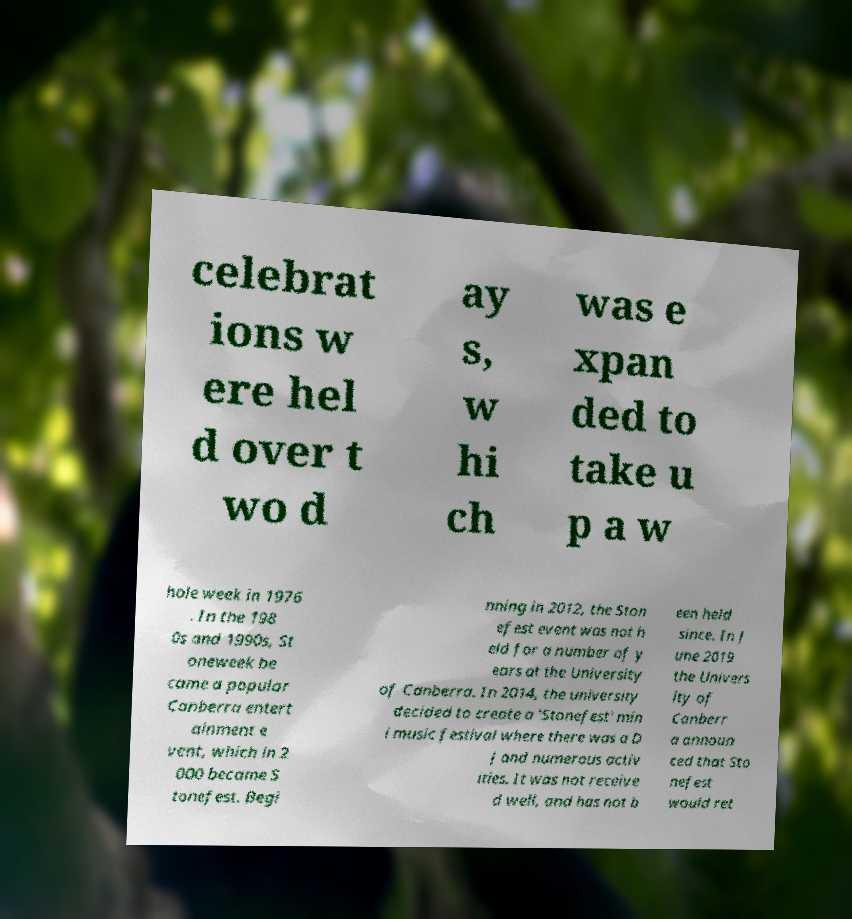For documentation purposes, I need the text within this image transcribed. Could you provide that? celebrat ions w ere hel d over t wo d ay s, w hi ch was e xpan ded to take u p a w hole week in 1976 . In the 198 0s and 1990s, St oneweek be came a popular Canberra entert ainment e vent, which in 2 000 became S tonefest. Begi nning in 2012, the Ston efest event was not h eld for a number of y ears at the University of Canberra. In 2014, the university decided to create a 'Stonefest' min i music festival where there was a D J and numerous activ ities. It was not receive d well, and has not b een held since. In J une 2019 the Univers ity of Canberr a announ ced that Sto nefest would ret 